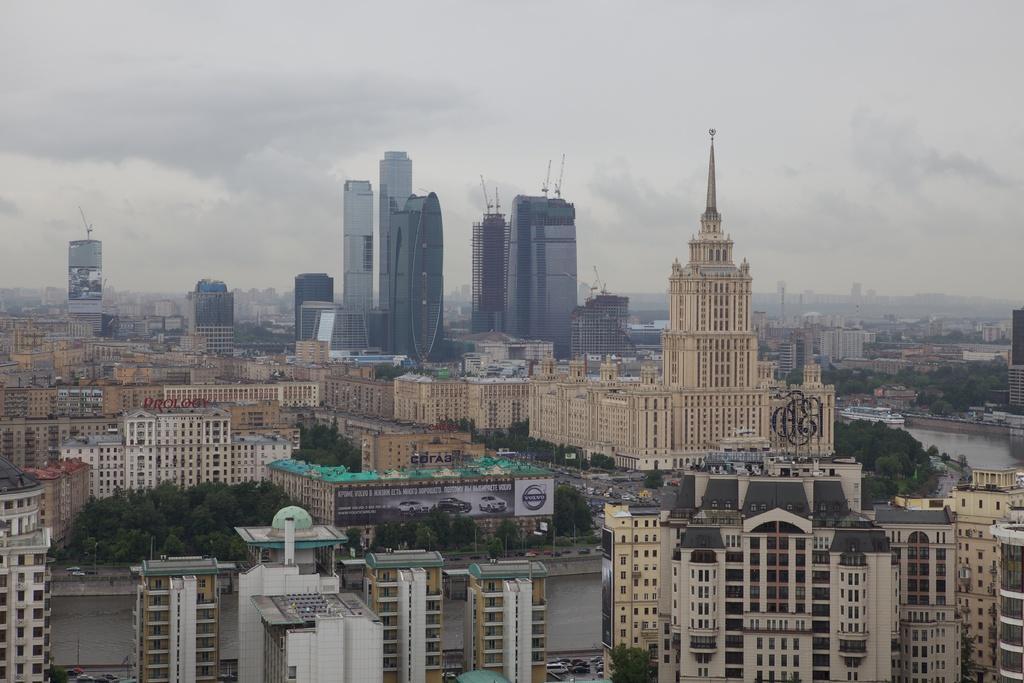Please provide a concise description of this image. At the bottom of the image we can see some trees, buildings, water and vehicles, On the water we can see some ships. At the top of the image we can see some clouds in the sky. 